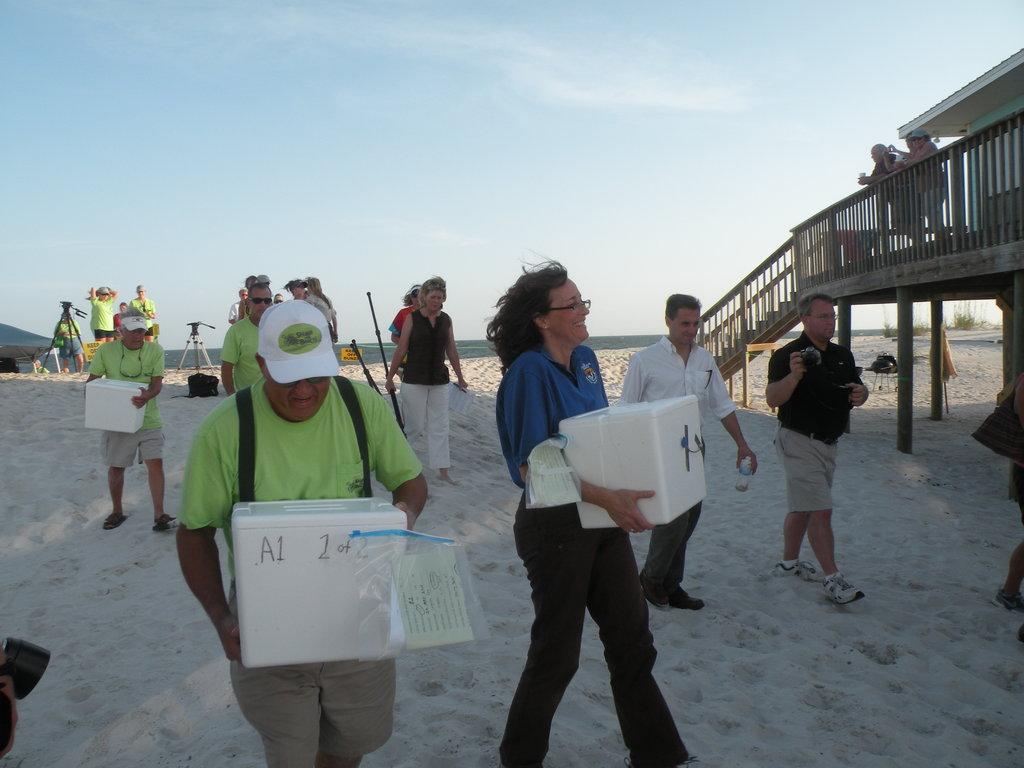Could you give a brief overview of what you see in this image? In this image I see number of people in which these 3 persons are holding a white container in their hands and I see that this man is holding a bottle and this man is holding a camera in his hand and this woman is holding a black stick and I see the sand. In the background I see an equipment over here and I see a house over here and I see the sky which is clear and I see the plants over here. 